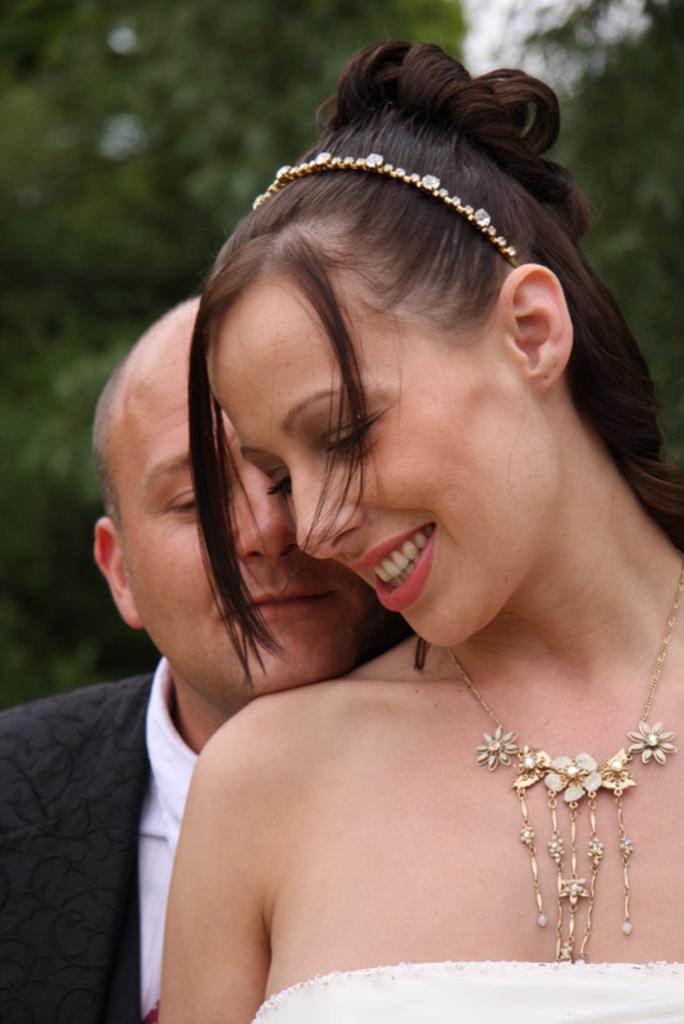Describe this image in one or two sentences. In this picture we can see there are two people standing and the woman is smiling. Behind the people there are trees and it looks like the sky. 